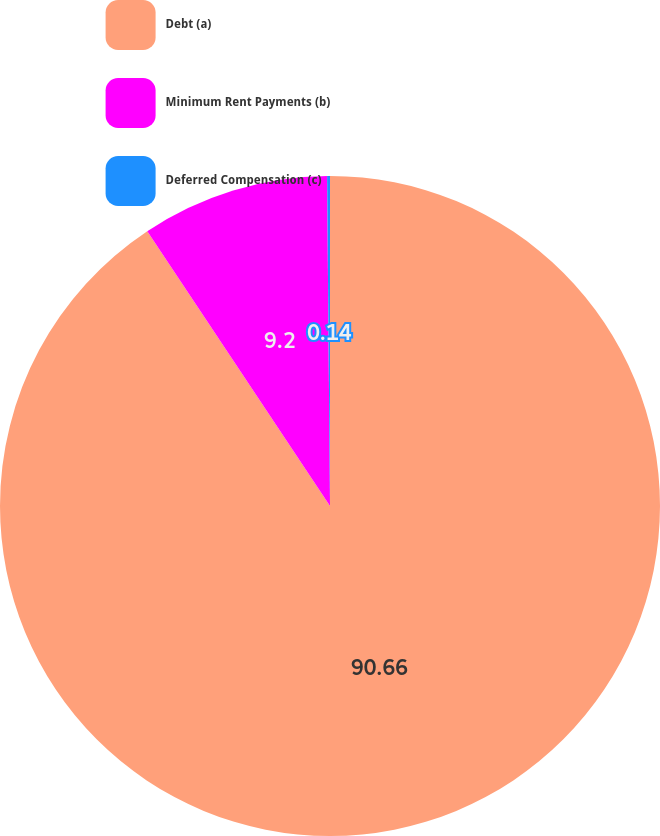<chart> <loc_0><loc_0><loc_500><loc_500><pie_chart><fcel>Debt (a)<fcel>Minimum Rent Payments (b)<fcel>Deferred Compensation (c)<nl><fcel>90.66%<fcel>9.2%<fcel>0.14%<nl></chart> 